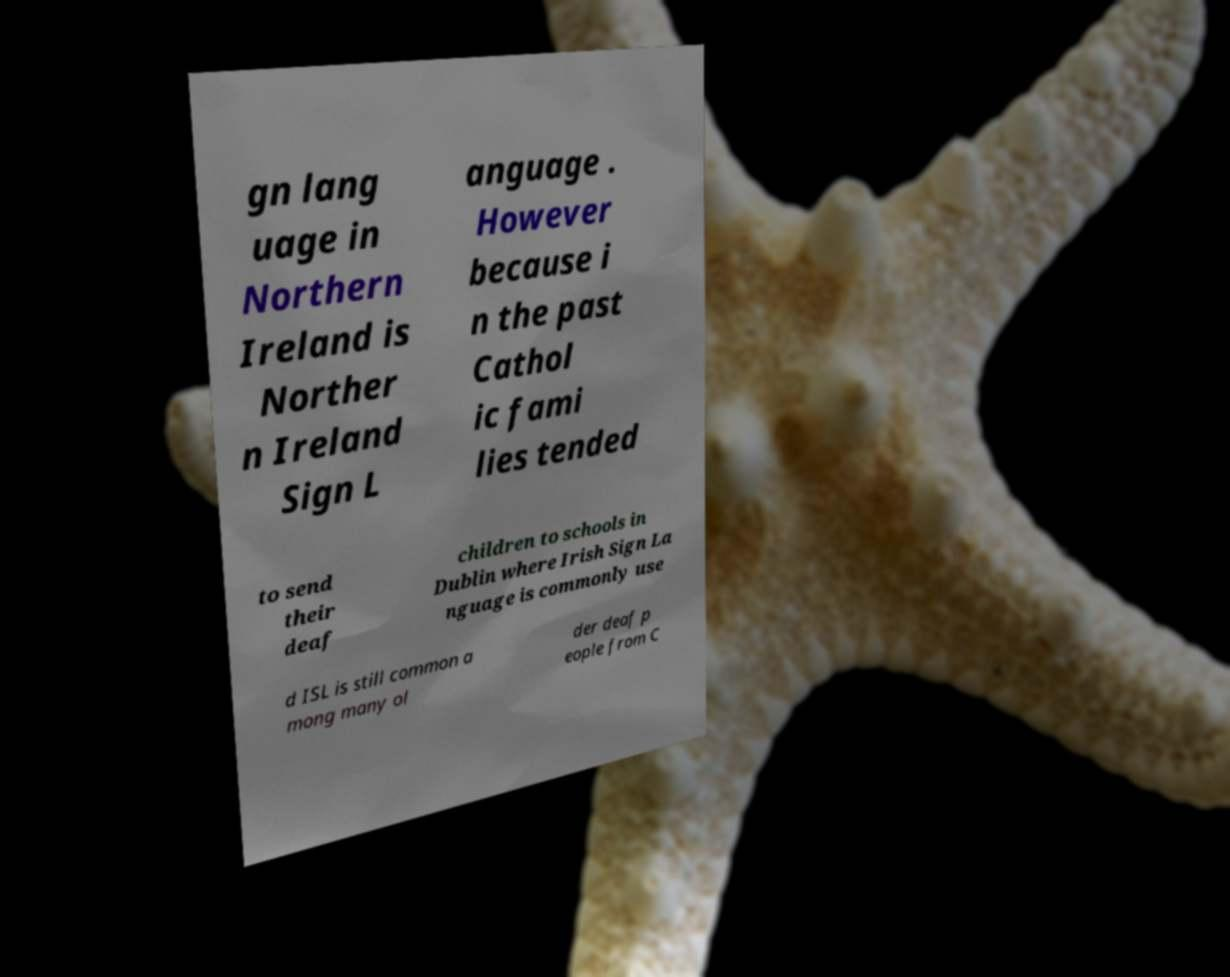Could you assist in decoding the text presented in this image and type it out clearly? gn lang uage in Northern Ireland is Norther n Ireland Sign L anguage . However because i n the past Cathol ic fami lies tended to send their deaf children to schools in Dublin where Irish Sign La nguage is commonly use d ISL is still common a mong many ol der deaf p eople from C 